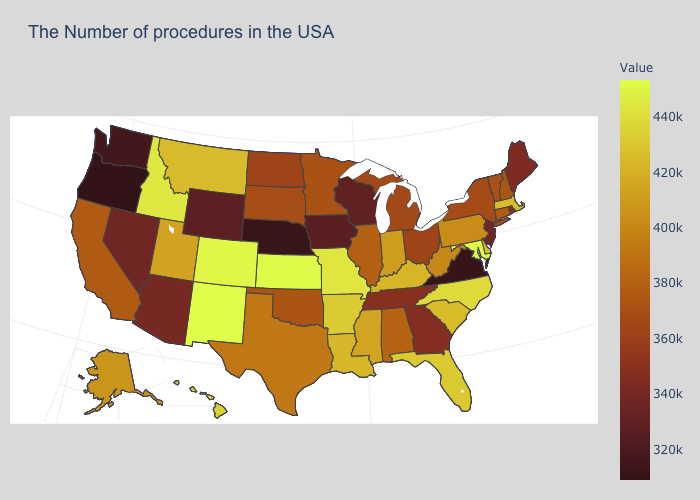Among the states that border New Jersey , which have the highest value?
Be succinct. Delaware. Does the map have missing data?
Write a very short answer. No. 